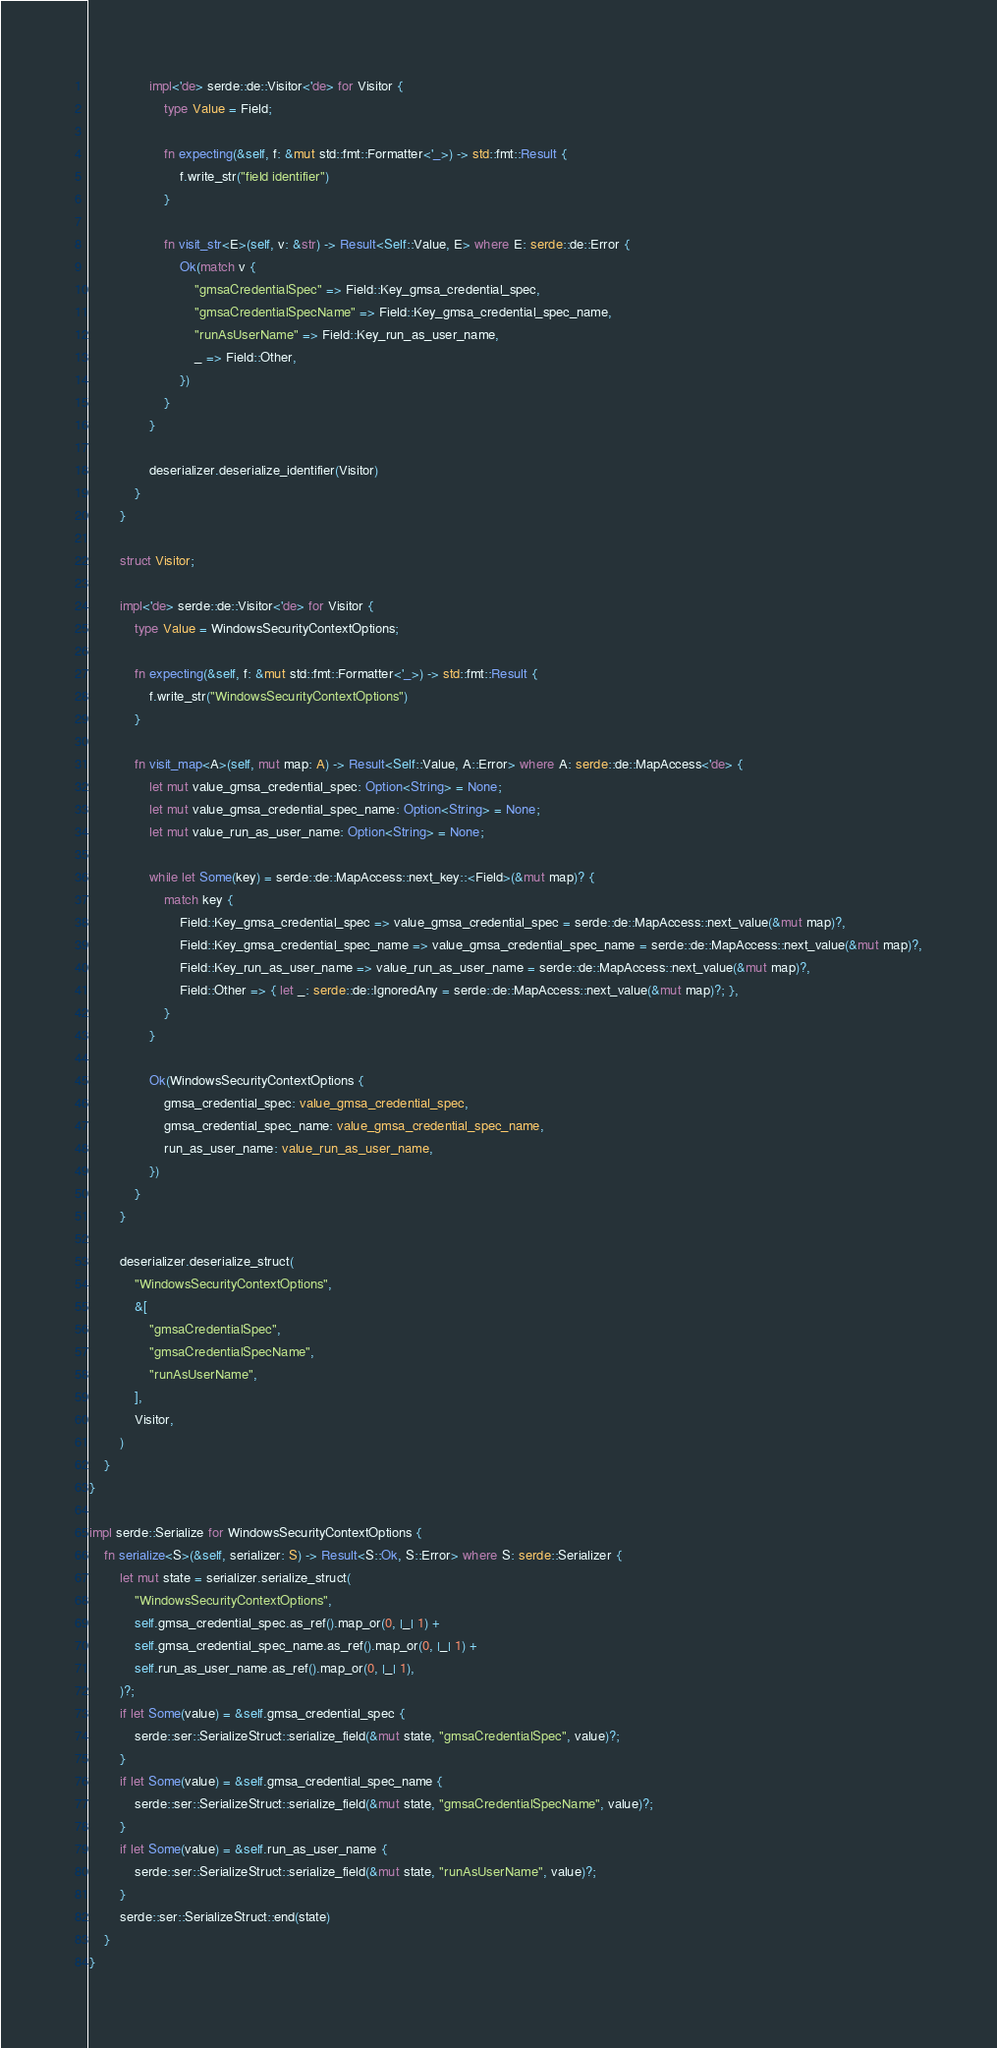Convert code to text. <code><loc_0><loc_0><loc_500><loc_500><_Rust_>
                impl<'de> serde::de::Visitor<'de> for Visitor {
                    type Value = Field;

                    fn expecting(&self, f: &mut std::fmt::Formatter<'_>) -> std::fmt::Result {
                        f.write_str("field identifier")
                    }

                    fn visit_str<E>(self, v: &str) -> Result<Self::Value, E> where E: serde::de::Error {
                        Ok(match v {
                            "gmsaCredentialSpec" => Field::Key_gmsa_credential_spec,
                            "gmsaCredentialSpecName" => Field::Key_gmsa_credential_spec_name,
                            "runAsUserName" => Field::Key_run_as_user_name,
                            _ => Field::Other,
                        })
                    }
                }

                deserializer.deserialize_identifier(Visitor)
            }
        }

        struct Visitor;

        impl<'de> serde::de::Visitor<'de> for Visitor {
            type Value = WindowsSecurityContextOptions;

            fn expecting(&self, f: &mut std::fmt::Formatter<'_>) -> std::fmt::Result {
                f.write_str("WindowsSecurityContextOptions")
            }

            fn visit_map<A>(self, mut map: A) -> Result<Self::Value, A::Error> where A: serde::de::MapAccess<'de> {
                let mut value_gmsa_credential_spec: Option<String> = None;
                let mut value_gmsa_credential_spec_name: Option<String> = None;
                let mut value_run_as_user_name: Option<String> = None;

                while let Some(key) = serde::de::MapAccess::next_key::<Field>(&mut map)? {
                    match key {
                        Field::Key_gmsa_credential_spec => value_gmsa_credential_spec = serde::de::MapAccess::next_value(&mut map)?,
                        Field::Key_gmsa_credential_spec_name => value_gmsa_credential_spec_name = serde::de::MapAccess::next_value(&mut map)?,
                        Field::Key_run_as_user_name => value_run_as_user_name = serde::de::MapAccess::next_value(&mut map)?,
                        Field::Other => { let _: serde::de::IgnoredAny = serde::de::MapAccess::next_value(&mut map)?; },
                    }
                }

                Ok(WindowsSecurityContextOptions {
                    gmsa_credential_spec: value_gmsa_credential_spec,
                    gmsa_credential_spec_name: value_gmsa_credential_spec_name,
                    run_as_user_name: value_run_as_user_name,
                })
            }
        }

        deserializer.deserialize_struct(
            "WindowsSecurityContextOptions",
            &[
                "gmsaCredentialSpec",
                "gmsaCredentialSpecName",
                "runAsUserName",
            ],
            Visitor,
        )
    }
}

impl serde::Serialize for WindowsSecurityContextOptions {
    fn serialize<S>(&self, serializer: S) -> Result<S::Ok, S::Error> where S: serde::Serializer {
        let mut state = serializer.serialize_struct(
            "WindowsSecurityContextOptions",
            self.gmsa_credential_spec.as_ref().map_or(0, |_| 1) +
            self.gmsa_credential_spec_name.as_ref().map_or(0, |_| 1) +
            self.run_as_user_name.as_ref().map_or(0, |_| 1),
        )?;
        if let Some(value) = &self.gmsa_credential_spec {
            serde::ser::SerializeStruct::serialize_field(&mut state, "gmsaCredentialSpec", value)?;
        }
        if let Some(value) = &self.gmsa_credential_spec_name {
            serde::ser::SerializeStruct::serialize_field(&mut state, "gmsaCredentialSpecName", value)?;
        }
        if let Some(value) = &self.run_as_user_name {
            serde::ser::SerializeStruct::serialize_field(&mut state, "runAsUserName", value)?;
        }
        serde::ser::SerializeStruct::end(state)
    }
}
</code> 